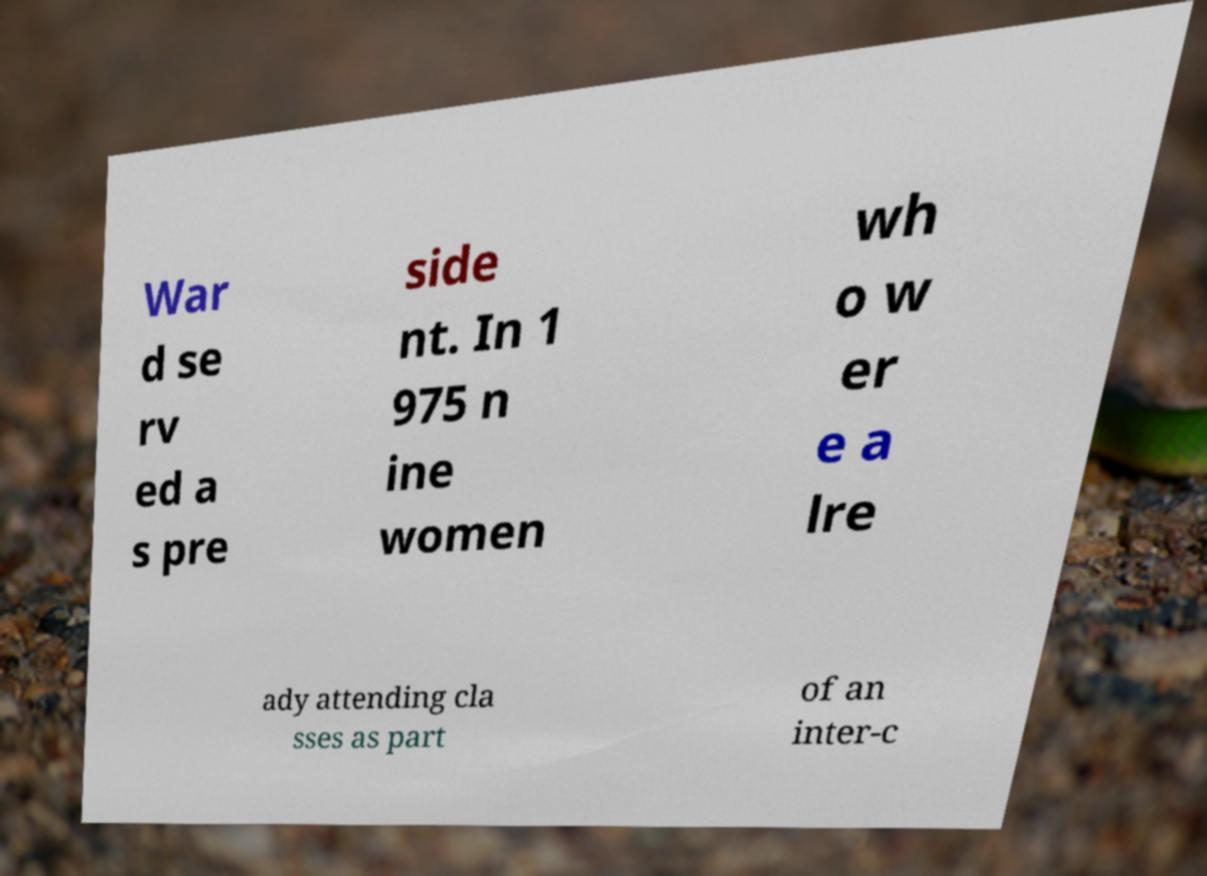Please read and relay the text visible in this image. What does it say? War d se rv ed a s pre side nt. In 1 975 n ine women wh o w er e a lre ady attending cla sses as part of an inter-c 